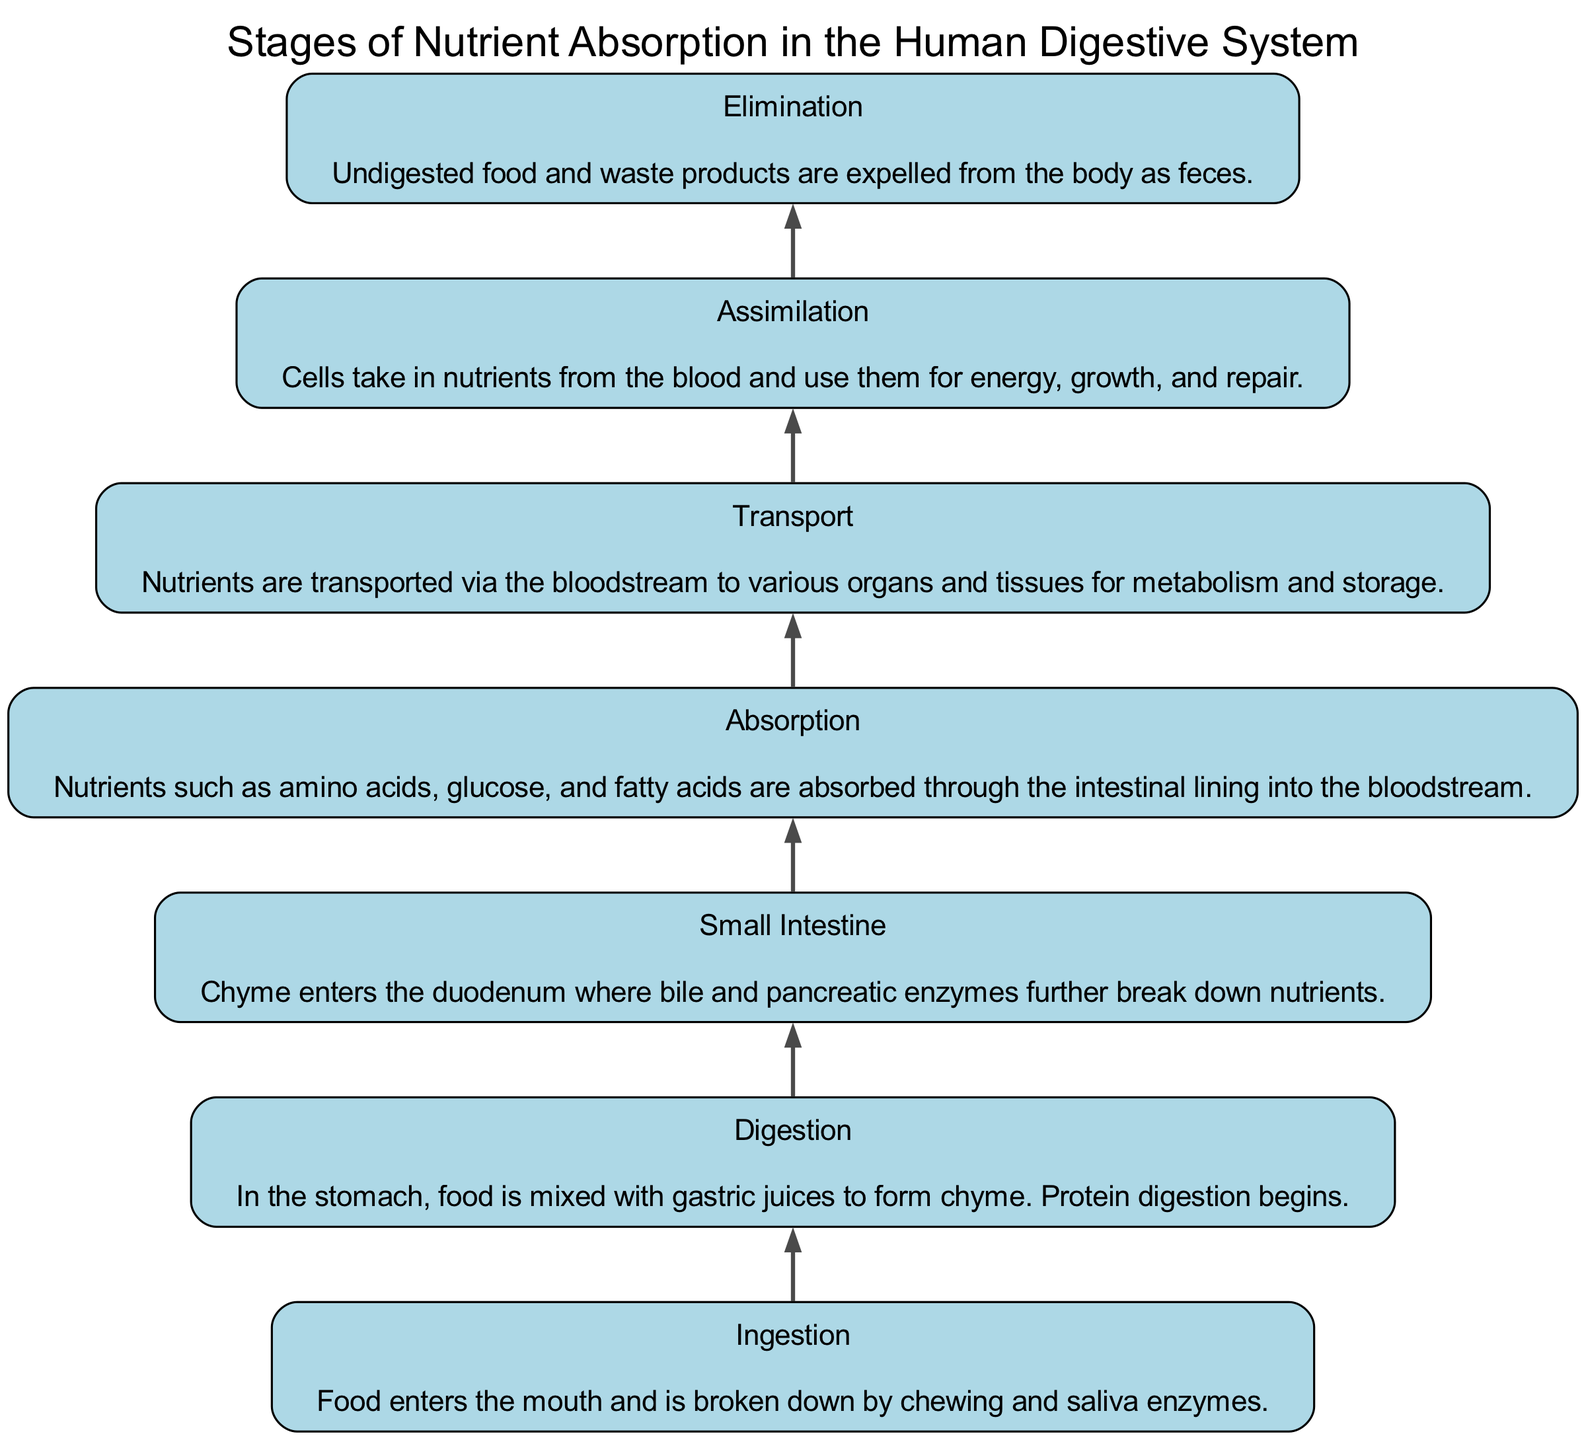What is the first stage of nutrient absorption? In the diagram, the first stage listed at the bottom is “Ingestion”, which describes the process of food entering the mouth and being broken down.
Answer: Ingestion How many stages are there in total? By counting the stages listed in the diagram, we find there are seven distinct stages representing the nutrient absorption process.
Answer: Seven What nutrient absorption stage follows digestion? The diagram shows that after the "Digestion" stage, the next stage is "Small Intestine", where chyme receives further breakdown.
Answer: Small Intestine Which stage involves the expulsion of waste products? The last stage at the top of the diagram is "Elimination", representing the process of expelling undigested food and waste from the body.
Answer: Elimination What is transported via the bloodstream? The "Transport" stage identifies that nutrients such as amino acids, glucose, and fatty acids are transported via the bloodstream to organs and tissues.
Answer: Nutrients Which stage involves cells using nutrients? According to the diagram, the "Assimilation" stage highlights that cells take in nutrients and utilize them for energy, growth, and repair.
Answer: Assimilation What process occurs in the small intestine? The "Small Intestine" stage indicates that enzymatic breakdown of nutrients occurs, involving bile and pancreatic enzymes to further digest chyme.
Answer: Enzymatic breakdown Which two stages directly precede assimilation? The stages that come before "Assimilation" are "Transport" and "Absorption", wherein nutrients are absorbed into the bloodstream and subsequently transported.
Answer: Transport and Absorption What happens during the digestion stage? The "Digestion" stage describes the process where food mixes with gastric juices, leading to the formation of chyme and the initiation of protein digestion.
Answer: Formation of chyme and protein digestion 